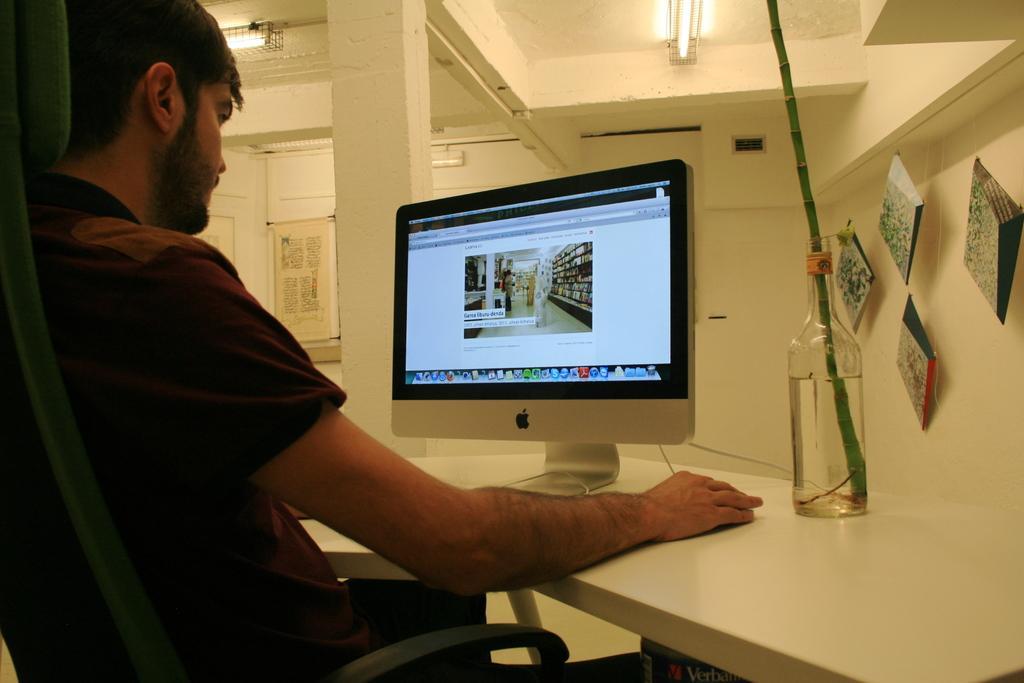In one or two sentences, can you explain what this image depicts? The picture is taken inside a room. A man is sitting on a chair. in front of him there is a table. On the table there is a desktop and a bottle with a plant stem and water. On the right hand side of the picture there are pictures. On the roof there are lights. 